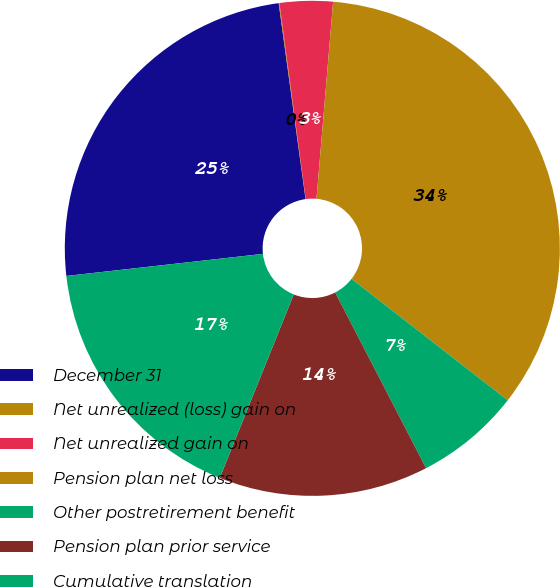<chart> <loc_0><loc_0><loc_500><loc_500><pie_chart><fcel>December 31<fcel>Net unrealized (loss) gain on<fcel>Net unrealized gain on<fcel>Pension plan net loss<fcel>Other postretirement benefit<fcel>Pension plan prior service<fcel>Cumulative translation<nl><fcel>24.61%<fcel>0.05%<fcel>3.46%<fcel>34.18%<fcel>6.88%<fcel>13.7%<fcel>17.12%<nl></chart> 